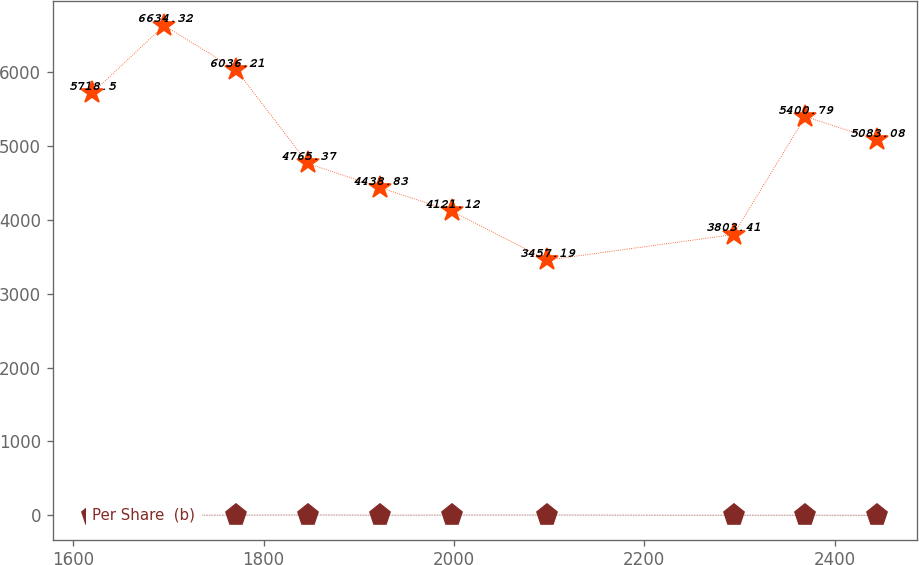<chart> <loc_0><loc_0><loc_500><loc_500><line_chart><ecel><fcel>Unnamed: 1<fcel>Per Share  (b)<nl><fcel>1619.81<fcel>5718.5<fcel>4.6<nl><fcel>1695.4<fcel>6634.32<fcel>2.52<nl><fcel>1770.99<fcel>6036.21<fcel>3.1<nl><fcel>1846.58<fcel>4765.37<fcel>3.98<nl><fcel>1922.17<fcel>4438.83<fcel>2.81<nl><fcel>1997.76<fcel>4121.12<fcel>3.4<nl><fcel>2098.24<fcel>3457.19<fcel>3.69<nl><fcel>2293.81<fcel>3803.41<fcel>1.94<nl><fcel>2369.4<fcel>5400.79<fcel>2.23<nl><fcel>2444.99<fcel>5083.08<fcel>1.65<nl></chart> 